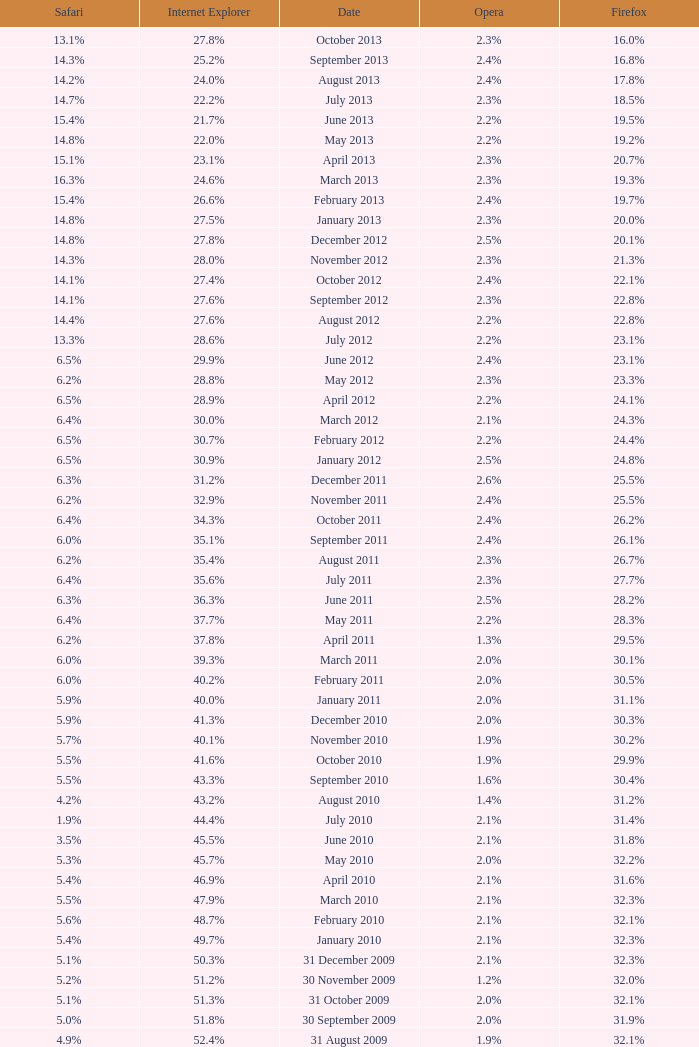What is the firefox value with a 1.9% safari? 31.4%. 